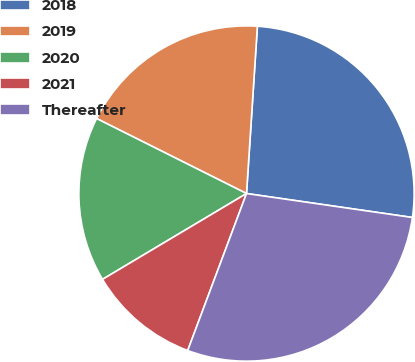Convert chart. <chart><loc_0><loc_0><loc_500><loc_500><pie_chart><fcel>2018<fcel>2019<fcel>2020<fcel>2021<fcel>Thereafter<nl><fcel>26.25%<fcel>18.65%<fcel>15.94%<fcel>10.74%<fcel>28.42%<nl></chart> 